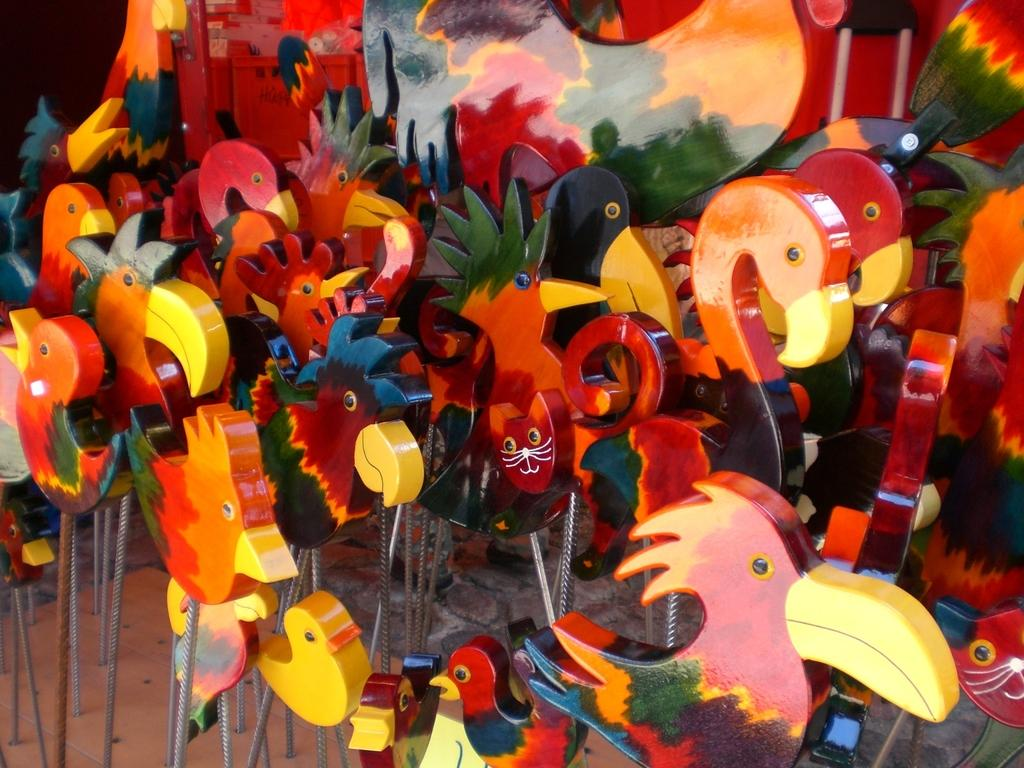What type of items can be seen in the image? There are toys in the image. Can you describe the toys in more detail? Unfortunately, the facts provided do not give specific details about the toys. Are there any other objects visible in the image besides the toys? Yes, there are objects in the image. However, the facts do not specify what these objects are. How many eggs are being cut with the scissors in the image? There are no eggs or scissors present in the image. What type of beam is supporting the structure in the image? There is no structure or beam present in the image. 